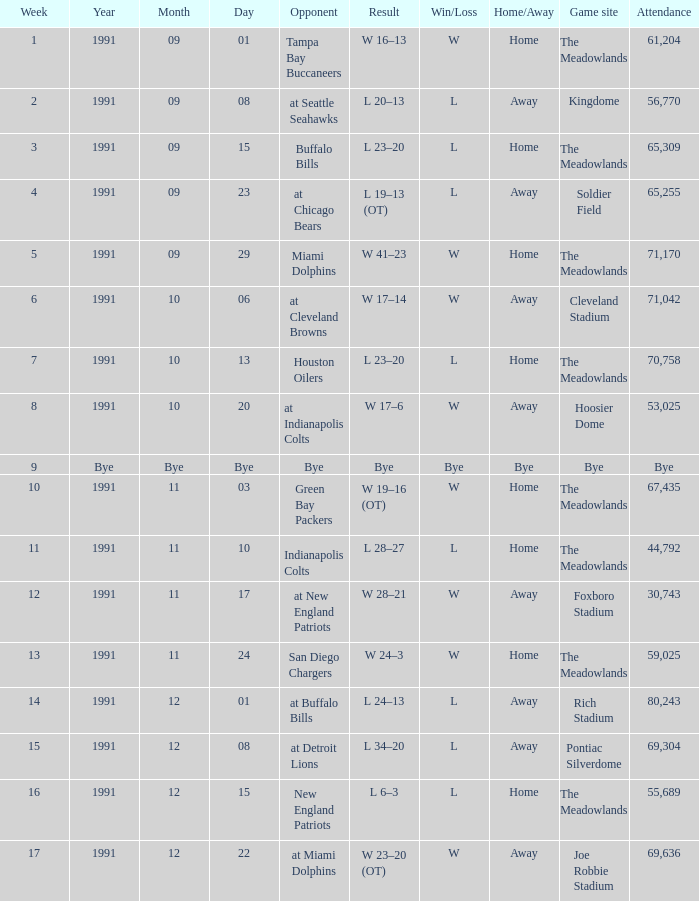Which Opponent was played on 1991-10-13? Houston Oilers. 